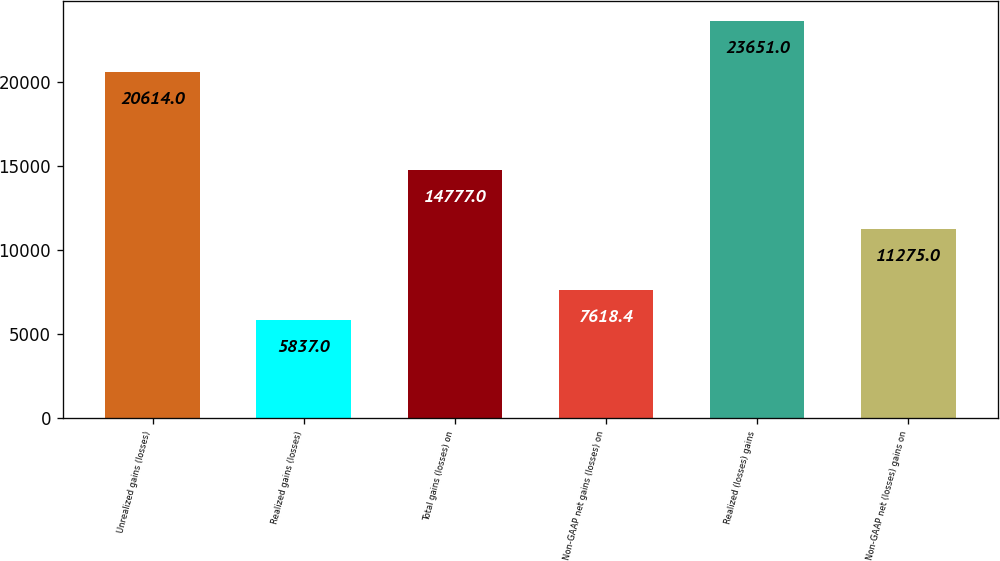<chart> <loc_0><loc_0><loc_500><loc_500><bar_chart><fcel>Unrealized gains (losses)<fcel>Realized gains (losses)<fcel>Total gains (losses) on<fcel>Non-GAAP net gains (losses) on<fcel>Realized (losses) gains<fcel>Non-GAAP net (losses) gains on<nl><fcel>20614<fcel>5837<fcel>14777<fcel>7618.4<fcel>23651<fcel>11275<nl></chart> 